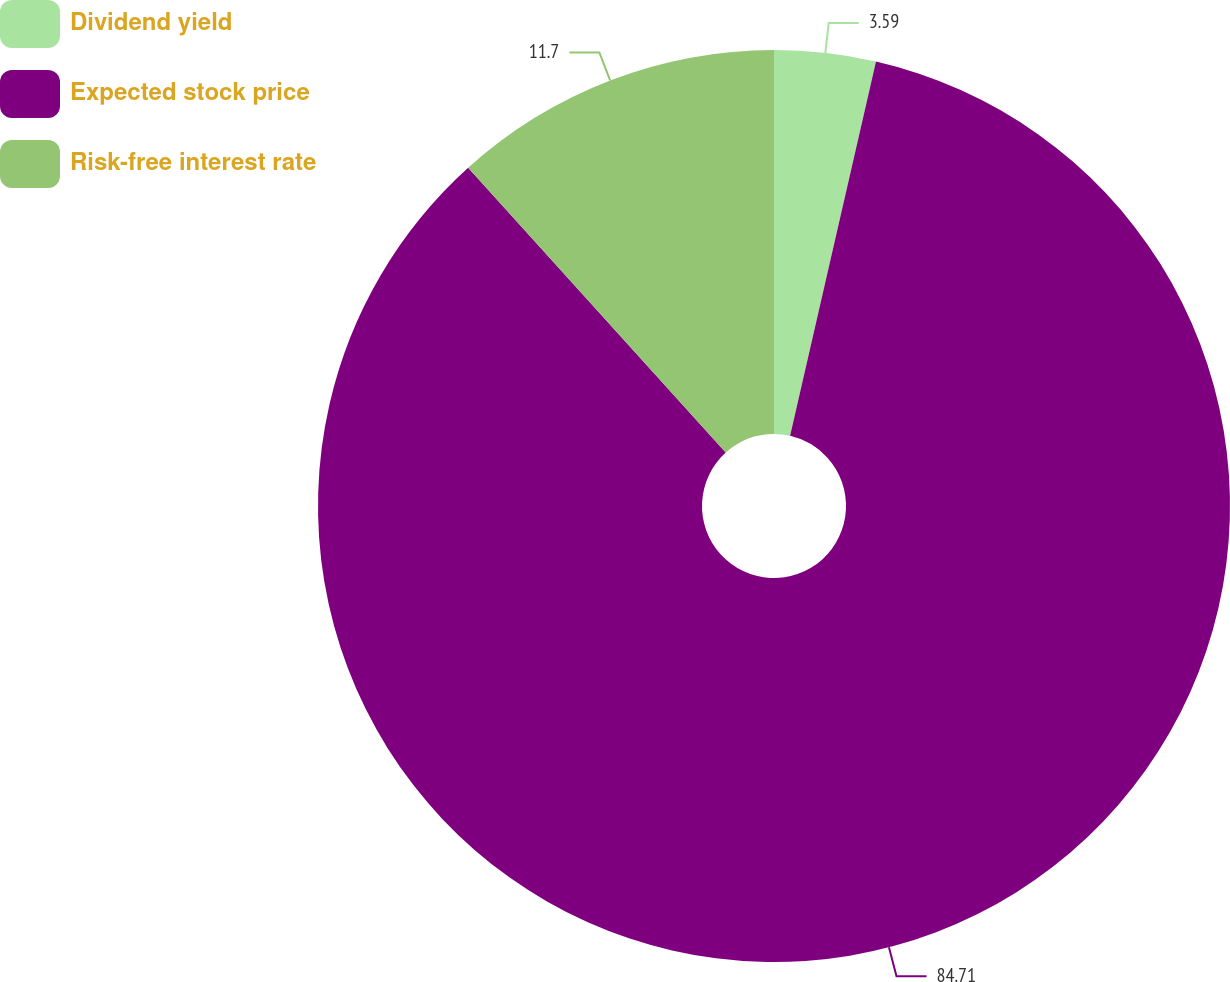Convert chart to OTSL. <chart><loc_0><loc_0><loc_500><loc_500><pie_chart><fcel>Dividend yield<fcel>Expected stock price<fcel>Risk-free interest rate<nl><fcel>3.59%<fcel>84.7%<fcel>11.7%<nl></chart> 